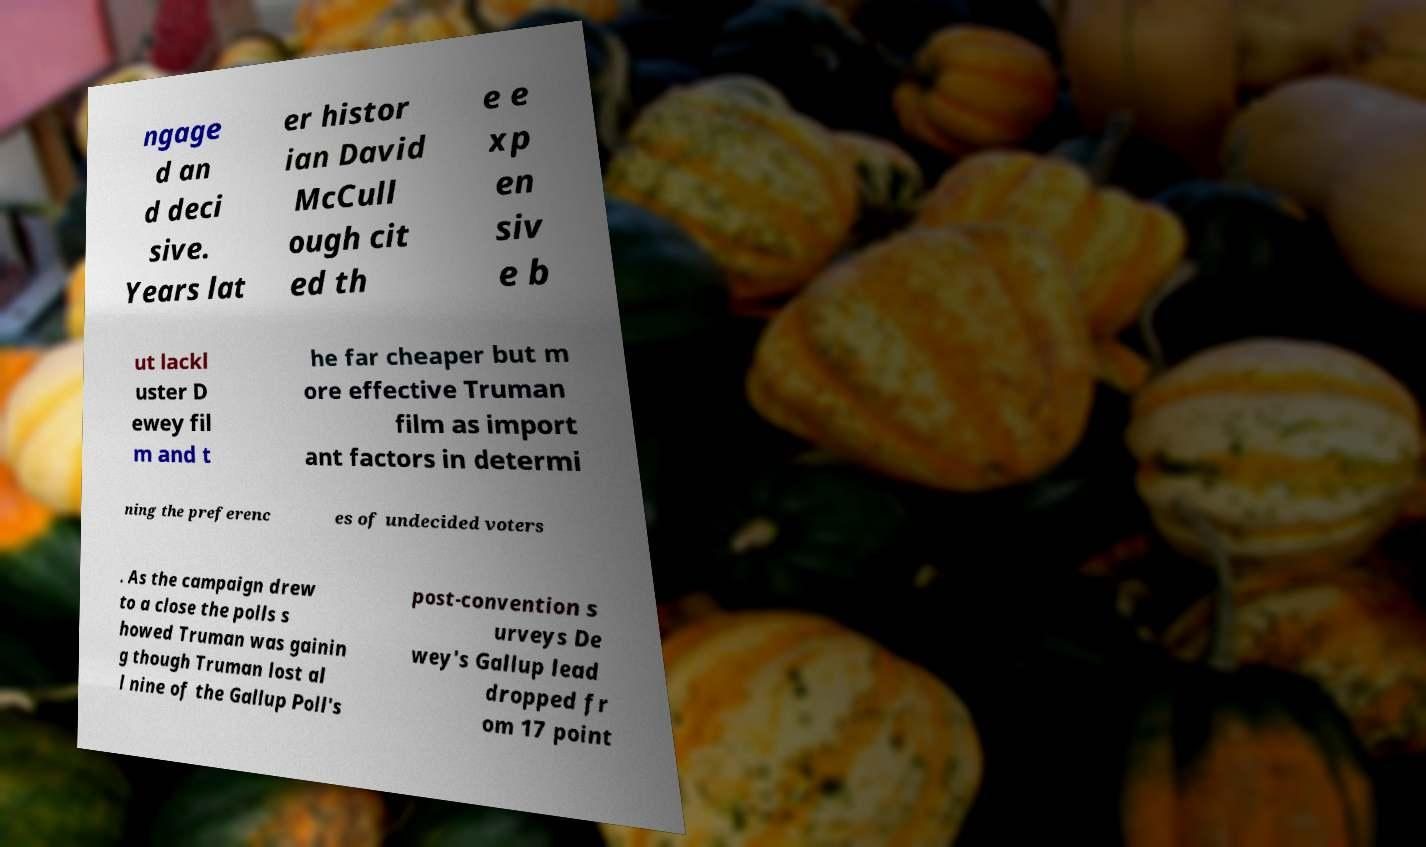Please read and relay the text visible in this image. What does it say? ngage d an d deci sive. Years lat er histor ian David McCull ough cit ed th e e xp en siv e b ut lackl uster D ewey fil m and t he far cheaper but m ore effective Truman film as import ant factors in determi ning the preferenc es of undecided voters . As the campaign drew to a close the polls s howed Truman was gainin g though Truman lost al l nine of the Gallup Poll's post-convention s urveys De wey's Gallup lead dropped fr om 17 point 